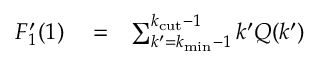<formula> <loc_0><loc_0><loc_500><loc_500>\begin{array} { r l r } { F _ { 1 } ^ { \prime } ( 1 ) } & = } & { \sum _ { k ^ { \prime } = k _ { \min } - 1 } ^ { k _ { c u t } - 1 } k ^ { \prime } Q ( k ^ { \prime } ) } \end{array}</formula> 